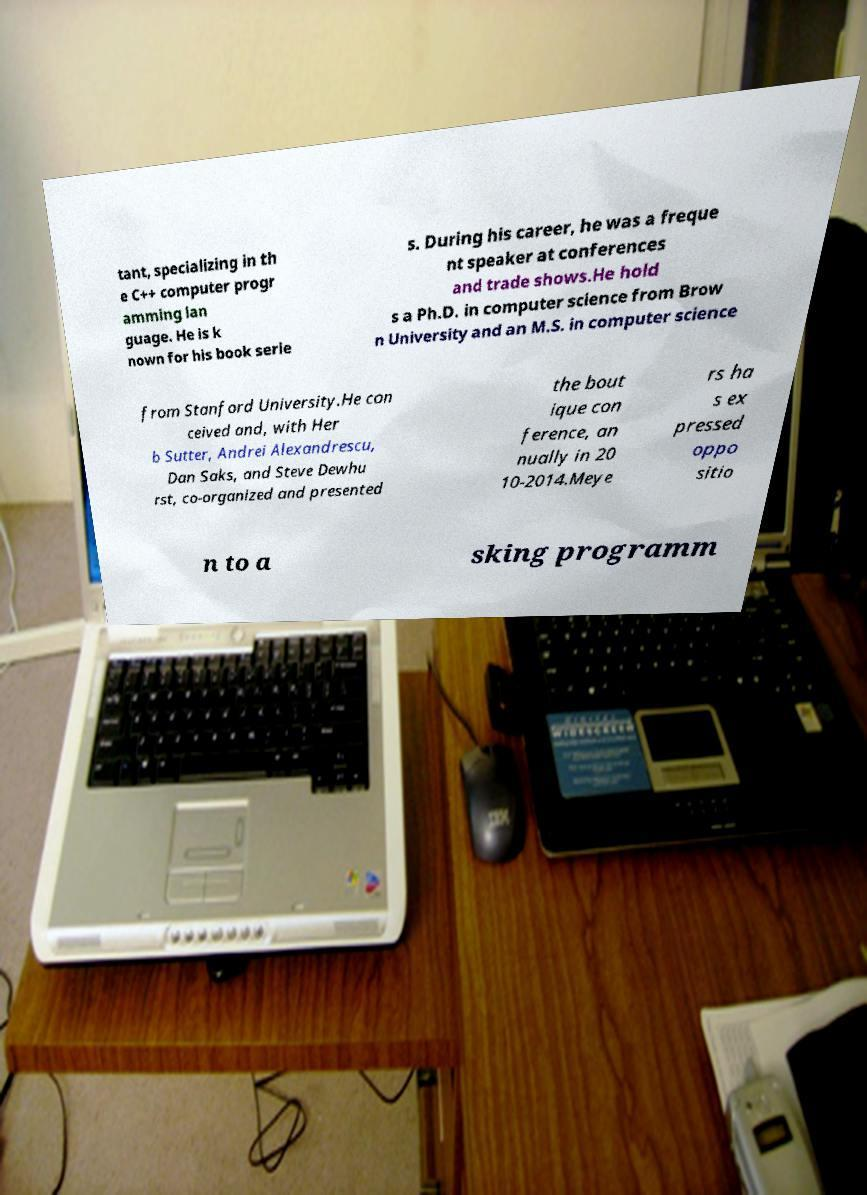For documentation purposes, I need the text within this image transcribed. Could you provide that? tant, specializing in th e C++ computer progr amming lan guage. He is k nown for his book serie s. During his career, he was a freque nt speaker at conferences and trade shows.He hold s a Ph.D. in computer science from Brow n University and an M.S. in computer science from Stanford University.He con ceived and, with Her b Sutter, Andrei Alexandrescu, Dan Saks, and Steve Dewhu rst, co-organized and presented the bout ique con ference, an nually in 20 10-2014.Meye rs ha s ex pressed oppo sitio n to a sking programm 